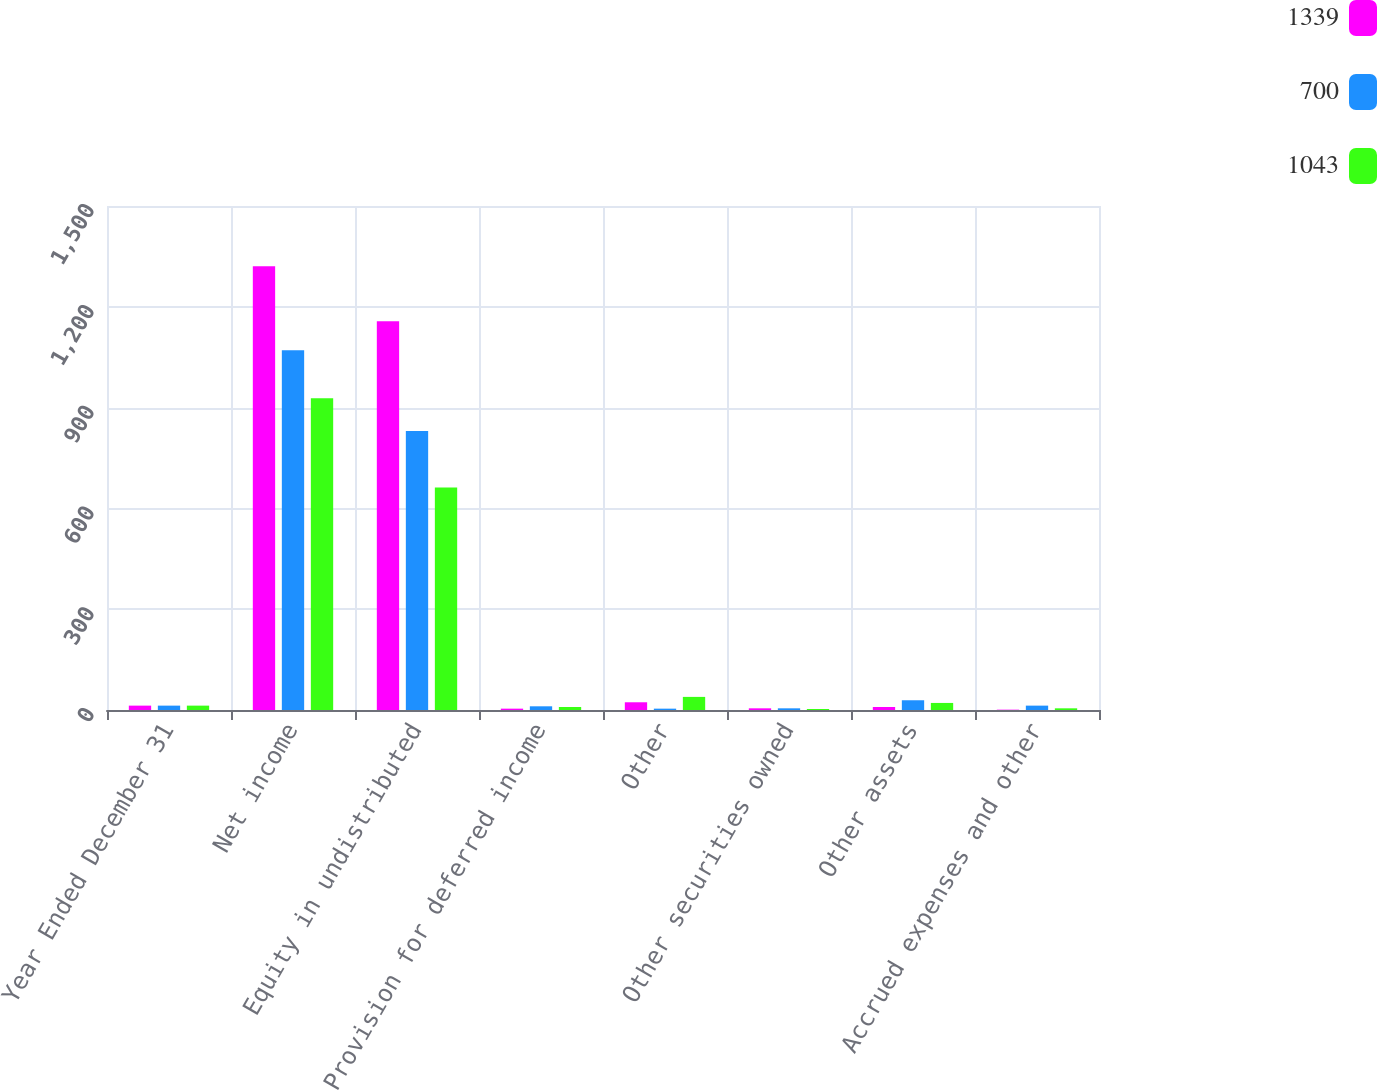Convert chart to OTSL. <chart><loc_0><loc_0><loc_500><loc_500><stacked_bar_chart><ecel><fcel>Year Ended December 31<fcel>Net income<fcel>Equity in undistributed<fcel>Provision for deferred income<fcel>Other<fcel>Other securities owned<fcel>Other assets<fcel>Accrued expenses and other<nl><fcel>1339<fcel>13<fcel>1321<fcel>1157<fcel>4<fcel>23<fcel>5<fcel>9<fcel>1<nl><fcel>700<fcel>13<fcel>1071<fcel>830<fcel>11<fcel>4<fcel>5<fcel>29<fcel>13<nl><fcel>1043<fcel>13<fcel>928<fcel>662<fcel>9<fcel>39<fcel>3<fcel>21<fcel>5<nl></chart> 